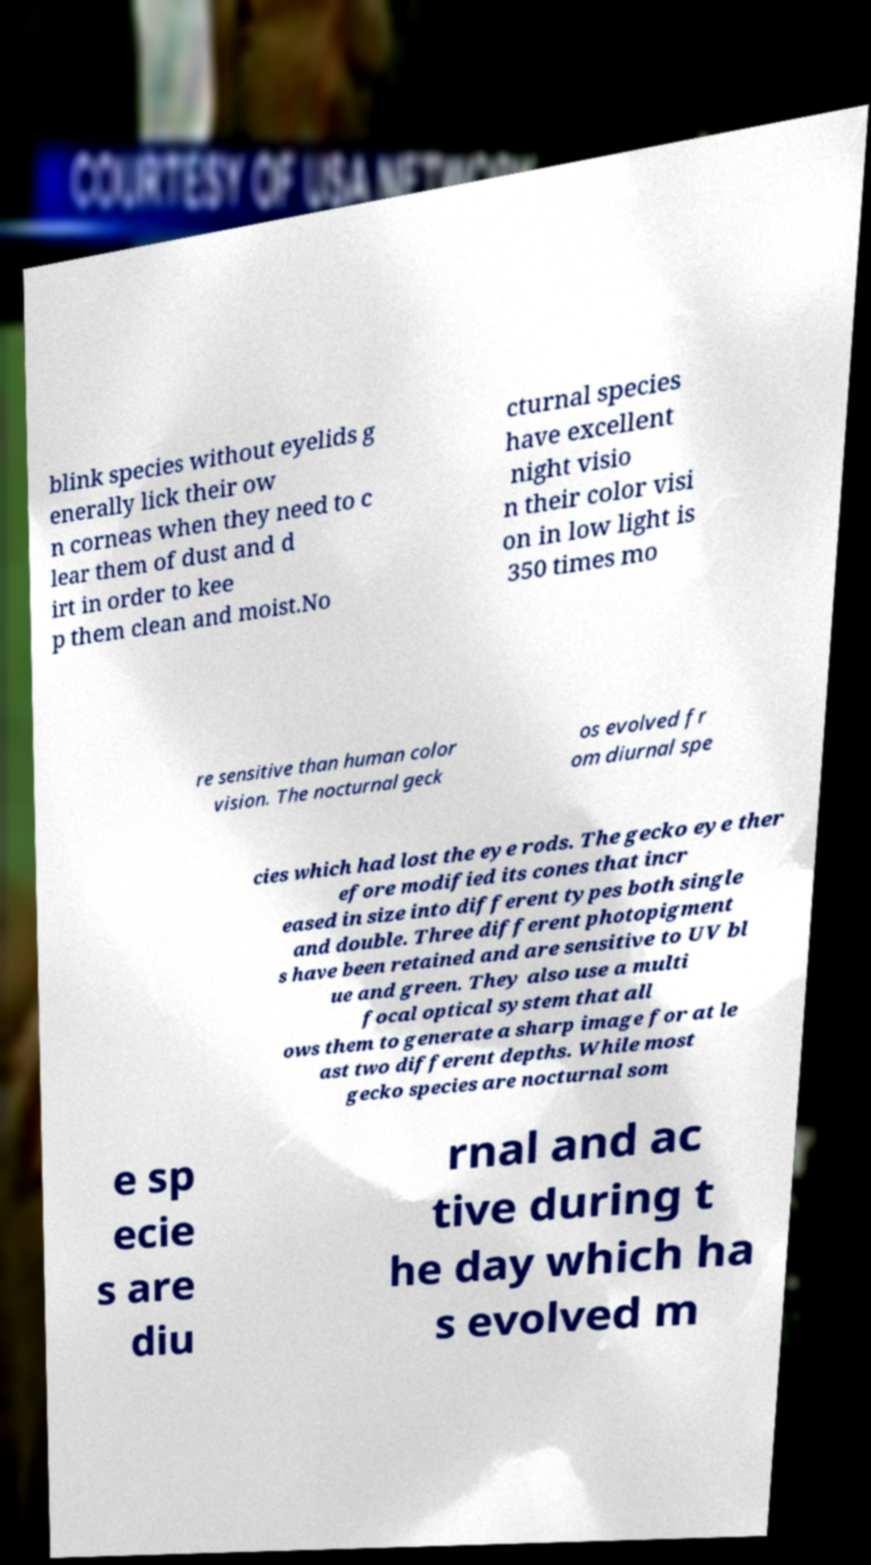There's text embedded in this image that I need extracted. Can you transcribe it verbatim? blink species without eyelids g enerally lick their ow n corneas when they need to c lear them of dust and d irt in order to kee p them clean and moist.No cturnal species have excellent night visio n their color visi on in low light is 350 times mo re sensitive than human color vision. The nocturnal geck os evolved fr om diurnal spe cies which had lost the eye rods. The gecko eye ther efore modified its cones that incr eased in size into different types both single and double. Three different photopigment s have been retained and are sensitive to UV bl ue and green. They also use a multi focal optical system that all ows them to generate a sharp image for at le ast two different depths. While most gecko species are nocturnal som e sp ecie s are diu rnal and ac tive during t he day which ha s evolved m 